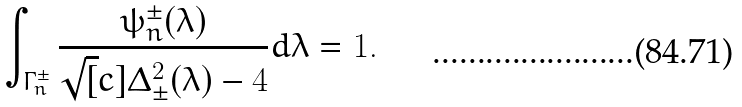<formula> <loc_0><loc_0><loc_500><loc_500>\int _ { \Gamma _ { n } ^ { \pm } } \frac { \psi _ { n } ^ { \pm } ( \lambda ) } { \sqrt { [ } c ] { \Delta ^ { 2 } _ { \pm } ( \lambda ) - 4 } } d \lambda = 1 .</formula> 